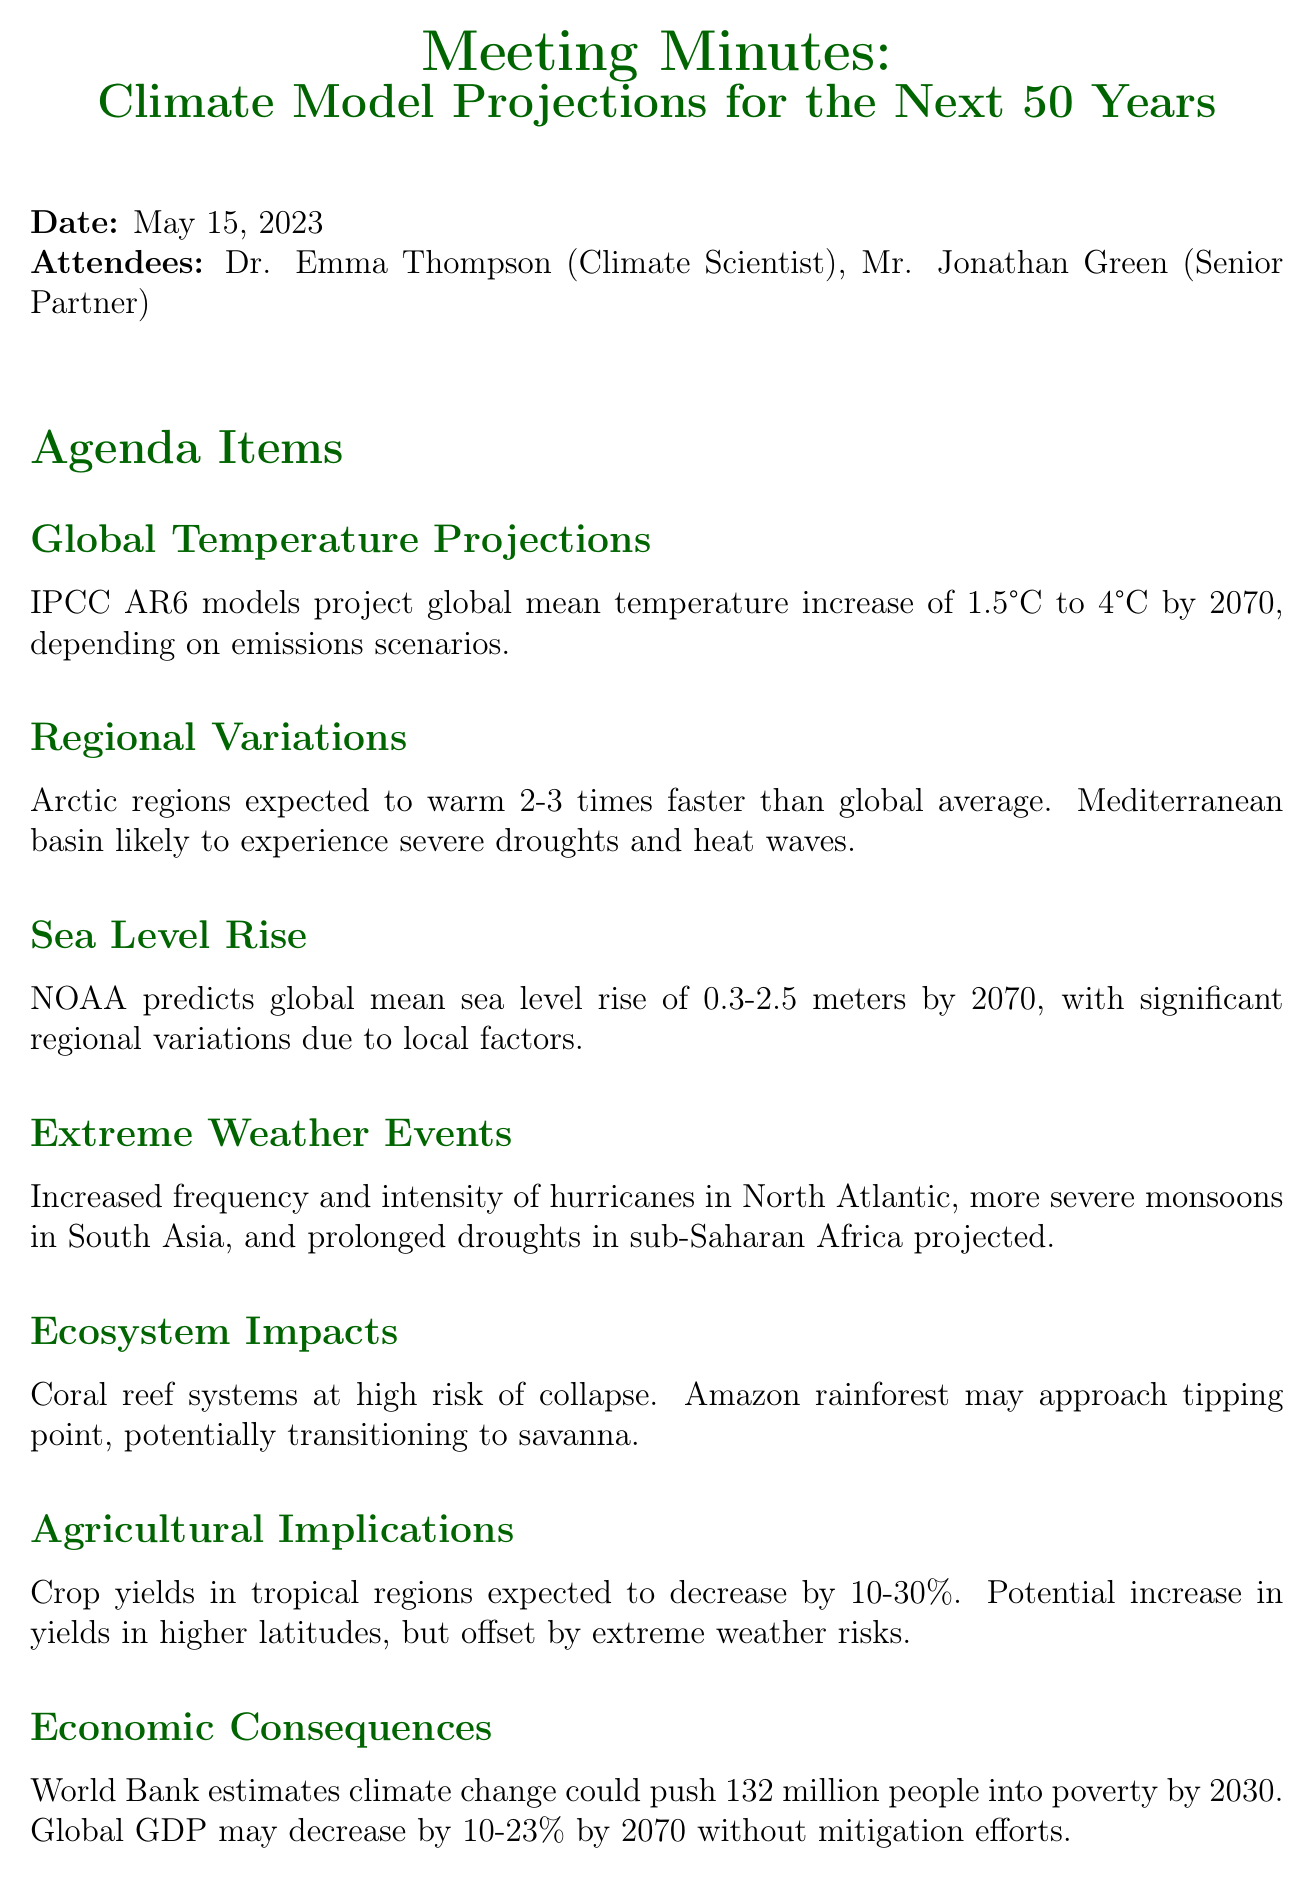What is the date of the meeting? The date of the meeting is explicitly mentioned in the document, which is May 15, 2023.
Answer: May 15, 2023 Who is the senior partner attending the meeting? The document lists the attendees, including the senior partner, Mr. Jonathan Green.
Answer: Mr. Jonathan Green What is the projected range of global mean temperature increase by 2070? The document specifies the increase forecasted by IPCC AR6 models, which is between 1.5°C to 4°C.
Answer: 1.5°C to 4°C What is the anticipated sea level rise by 2070 according to NOAA? The anticipated sea level rise is provided in the document as a range of 0.3 to 2.5 meters.
Answer: 0.3-2.5 meters What is the expected decrease in crop yields in tropical regions? The document outlines the decrease in crop yields as being between 10-30%.
Answer: 10-30% Which ecosystem is at high risk of collapse? The document identifies the coral reef systems as being at high risk of collapse.
Answer: Coral reef systems What impact could climate change have on poverty by 2030? The document cites an estimation by the World Bank regarding the potential impact of climate change on poverty, specifically pushing 132 million people into poverty.
Answer: 132 million people What is one action item from the meeting? The document lists action items, one of which is to prepare a detailed report on regional climate projections.
Answer: Prepare detailed report on regional climate projections What type of meeting is this document documenting? The document is structured as minutes for a meeting discussing projections and impacts related to climate models.
Answer: Meeting minutes 